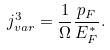<formula> <loc_0><loc_0><loc_500><loc_500>j ^ { 3 } _ { v a r } = \frac { 1 } { \Omega } \frac { p _ { F } } { E _ { F } ^ { * } } .</formula> 